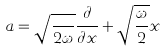<formula> <loc_0><loc_0><loc_500><loc_500>a = \sqrt { \frac { } { 2 \omega } } \frac { \partial } { \partial x } + \sqrt { \frac { \omega } { 2 } } x</formula> 